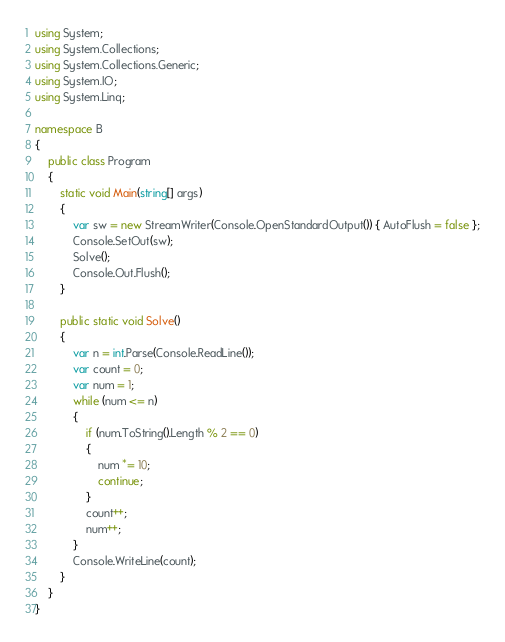Convert code to text. <code><loc_0><loc_0><loc_500><loc_500><_C#_>using System;
using System.Collections;
using System.Collections.Generic;
using System.IO;
using System.Linq;

namespace B
{
    public class Program
    {
        static void Main(string[] args)
        {
            var sw = new StreamWriter(Console.OpenStandardOutput()) { AutoFlush = false };
            Console.SetOut(sw);
            Solve();
            Console.Out.Flush();
        }

        public static void Solve()
        {
            var n = int.Parse(Console.ReadLine());
            var count = 0;
            var num = 1;
            while (num <= n)
            {
                if (num.ToString().Length % 2 == 0)
                {
                    num *= 10;
                    continue;
                }
                count++;
                num++;
            }
            Console.WriteLine(count);
        }
    }
}
</code> 